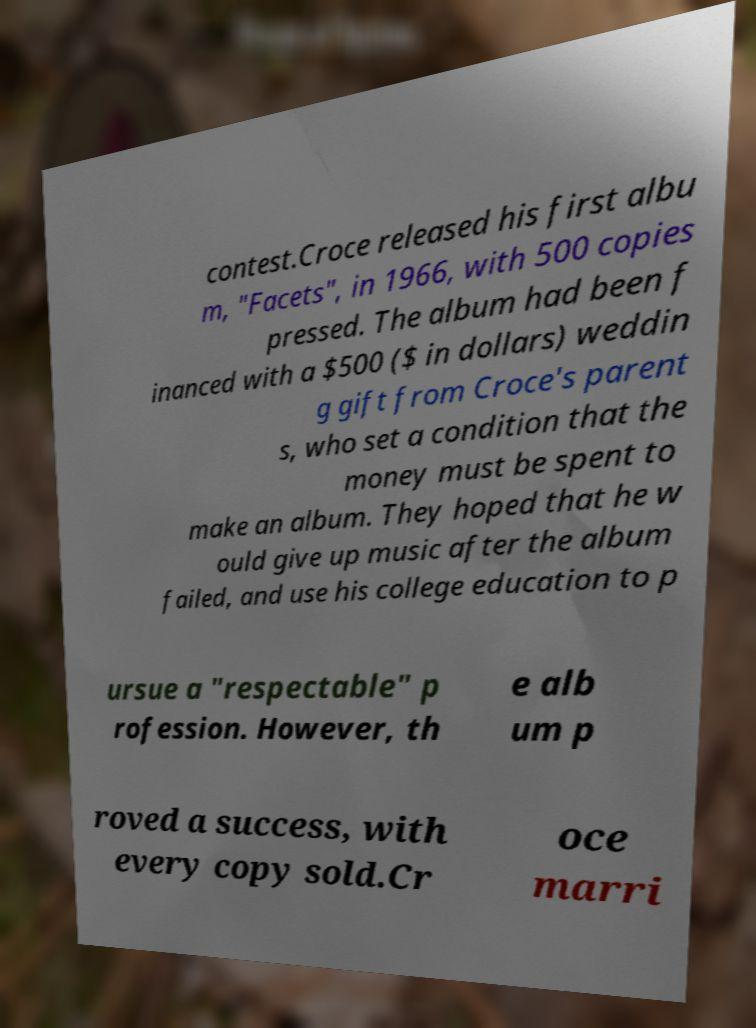Can you accurately transcribe the text from the provided image for me? contest.Croce released his first albu m, "Facets", in 1966, with 500 copies pressed. The album had been f inanced with a $500 ($ in dollars) weddin g gift from Croce's parent s, who set a condition that the money must be spent to make an album. They hoped that he w ould give up music after the album failed, and use his college education to p ursue a "respectable" p rofession. However, th e alb um p roved a success, with every copy sold.Cr oce marri 